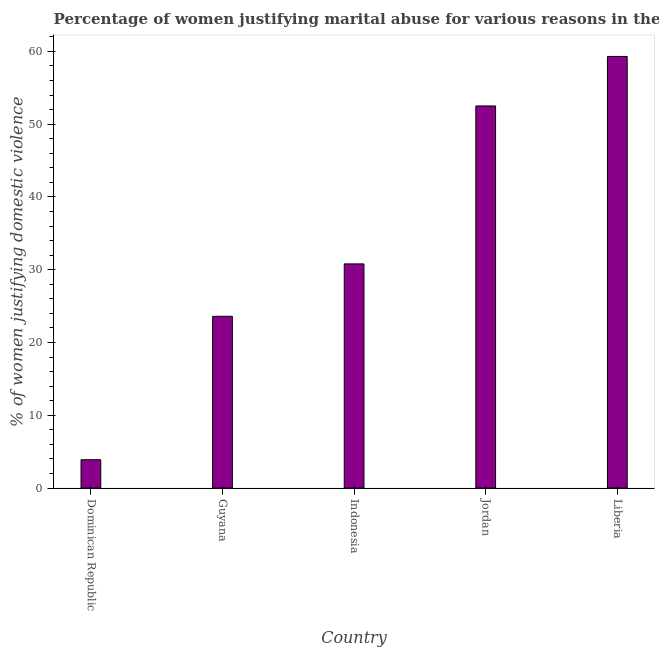Does the graph contain any zero values?
Your response must be concise. No. What is the title of the graph?
Provide a succinct answer. Percentage of women justifying marital abuse for various reasons in the year 2007. What is the label or title of the Y-axis?
Your answer should be very brief. % of women justifying domestic violence. What is the percentage of women justifying marital abuse in Guyana?
Keep it short and to the point. 23.6. Across all countries, what is the maximum percentage of women justifying marital abuse?
Provide a succinct answer. 59.3. Across all countries, what is the minimum percentage of women justifying marital abuse?
Provide a short and direct response. 3.9. In which country was the percentage of women justifying marital abuse maximum?
Provide a short and direct response. Liberia. In which country was the percentage of women justifying marital abuse minimum?
Offer a terse response. Dominican Republic. What is the sum of the percentage of women justifying marital abuse?
Your response must be concise. 170.1. What is the difference between the percentage of women justifying marital abuse in Dominican Republic and Jordan?
Keep it short and to the point. -48.6. What is the average percentage of women justifying marital abuse per country?
Your answer should be compact. 34.02. What is the median percentage of women justifying marital abuse?
Keep it short and to the point. 30.8. What is the ratio of the percentage of women justifying marital abuse in Dominican Republic to that in Guyana?
Provide a short and direct response. 0.17. Is the percentage of women justifying marital abuse in Jordan less than that in Liberia?
Give a very brief answer. Yes. Is the difference between the percentage of women justifying marital abuse in Guyana and Jordan greater than the difference between any two countries?
Your answer should be compact. No. What is the difference between the highest and the second highest percentage of women justifying marital abuse?
Make the answer very short. 6.8. What is the difference between the highest and the lowest percentage of women justifying marital abuse?
Provide a short and direct response. 55.4. In how many countries, is the percentage of women justifying marital abuse greater than the average percentage of women justifying marital abuse taken over all countries?
Offer a very short reply. 2. Are all the bars in the graph horizontal?
Offer a terse response. No. How many countries are there in the graph?
Make the answer very short. 5. Are the values on the major ticks of Y-axis written in scientific E-notation?
Keep it short and to the point. No. What is the % of women justifying domestic violence of Dominican Republic?
Your response must be concise. 3.9. What is the % of women justifying domestic violence in Guyana?
Offer a very short reply. 23.6. What is the % of women justifying domestic violence in Indonesia?
Keep it short and to the point. 30.8. What is the % of women justifying domestic violence of Jordan?
Your answer should be compact. 52.5. What is the % of women justifying domestic violence of Liberia?
Your response must be concise. 59.3. What is the difference between the % of women justifying domestic violence in Dominican Republic and Guyana?
Give a very brief answer. -19.7. What is the difference between the % of women justifying domestic violence in Dominican Republic and Indonesia?
Your response must be concise. -26.9. What is the difference between the % of women justifying domestic violence in Dominican Republic and Jordan?
Your answer should be compact. -48.6. What is the difference between the % of women justifying domestic violence in Dominican Republic and Liberia?
Provide a short and direct response. -55.4. What is the difference between the % of women justifying domestic violence in Guyana and Jordan?
Make the answer very short. -28.9. What is the difference between the % of women justifying domestic violence in Guyana and Liberia?
Provide a succinct answer. -35.7. What is the difference between the % of women justifying domestic violence in Indonesia and Jordan?
Provide a short and direct response. -21.7. What is the difference between the % of women justifying domestic violence in Indonesia and Liberia?
Offer a very short reply. -28.5. What is the difference between the % of women justifying domestic violence in Jordan and Liberia?
Keep it short and to the point. -6.8. What is the ratio of the % of women justifying domestic violence in Dominican Republic to that in Guyana?
Your answer should be compact. 0.17. What is the ratio of the % of women justifying domestic violence in Dominican Republic to that in Indonesia?
Your response must be concise. 0.13. What is the ratio of the % of women justifying domestic violence in Dominican Republic to that in Jordan?
Ensure brevity in your answer.  0.07. What is the ratio of the % of women justifying domestic violence in Dominican Republic to that in Liberia?
Ensure brevity in your answer.  0.07. What is the ratio of the % of women justifying domestic violence in Guyana to that in Indonesia?
Offer a terse response. 0.77. What is the ratio of the % of women justifying domestic violence in Guyana to that in Jordan?
Your answer should be very brief. 0.45. What is the ratio of the % of women justifying domestic violence in Guyana to that in Liberia?
Offer a terse response. 0.4. What is the ratio of the % of women justifying domestic violence in Indonesia to that in Jordan?
Offer a very short reply. 0.59. What is the ratio of the % of women justifying domestic violence in Indonesia to that in Liberia?
Offer a very short reply. 0.52. What is the ratio of the % of women justifying domestic violence in Jordan to that in Liberia?
Offer a very short reply. 0.89. 